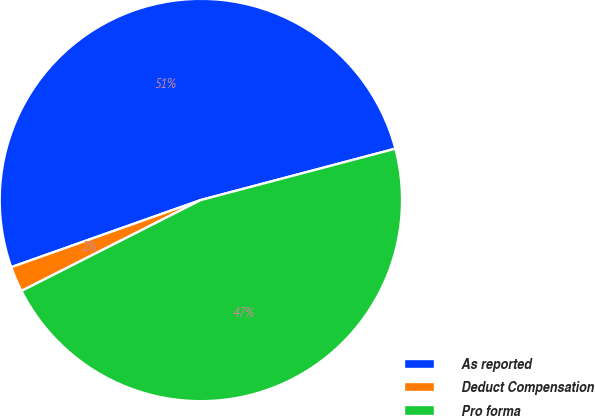Convert chart to OTSL. <chart><loc_0><loc_0><loc_500><loc_500><pie_chart><fcel>As reported<fcel>Deduct Compensation<fcel>Pro forma<nl><fcel>51.31%<fcel>2.05%<fcel>46.64%<nl></chart> 